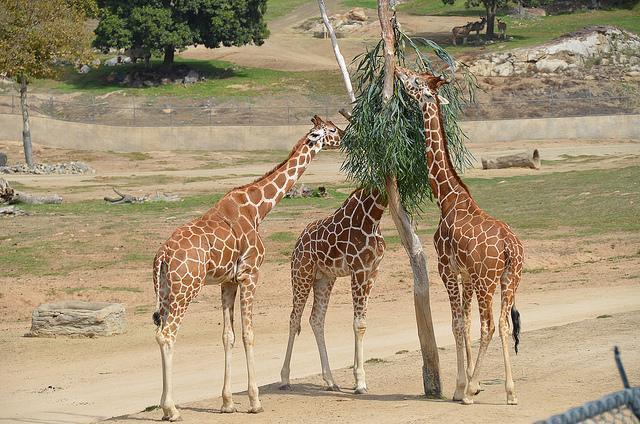How many animals are there?
Give a very brief answer. 3. How many legs do these animals have altogether?
Give a very brief answer. 12. How many giraffes are there?
Give a very brief answer. 3. 